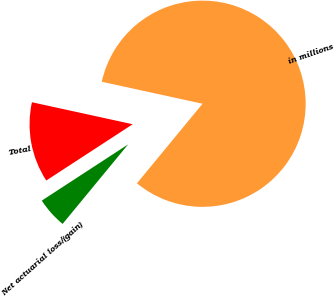Convert chart. <chart><loc_0><loc_0><loc_500><loc_500><pie_chart><fcel>in millions<fcel>Net actuarial loss/(gain)<fcel>Total<nl><fcel>82.55%<fcel>4.84%<fcel>12.61%<nl></chart> 